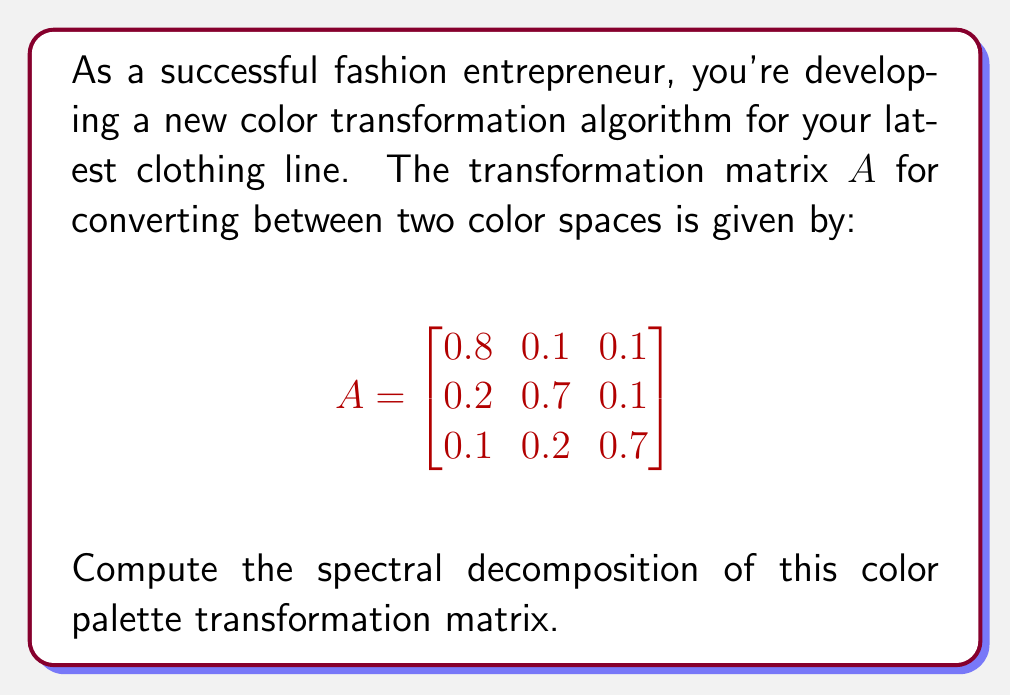Show me your answer to this math problem. To find the spectral decomposition of matrix $A$, we need to follow these steps:

1) Find the eigenvalues of $A$:
   Solve the characteristic equation $\det(A - \lambda I) = 0$
   
   $$\det\begin{pmatrix}
   0.8-\lambda & 0.1 & 0.1 \\
   0.2 & 0.7-\lambda & 0.1 \\
   0.1 & 0.2 & 0.7-\lambda
   \end{pmatrix} = 0$$
   
   Expanding this, we get:
   $-\lambda^3 + 2.2\lambda^2 - 1.51\lambda + 0.308 = 0$
   
   Solving this equation, we find the eigenvalues:
   $\lambda_1 = 1, \lambda_2 = 0.6, \lambda_3 = 0.6$

2) Find the eigenvectors for each eigenvalue:

   For $\lambda_1 = 1$:
   $(A - I)\vec{v_1} = 0$ gives $\vec{v_1} = (1, 1, 1)^T$

   For $\lambda_2 = \lambda_3 = 0.6$:
   $(A - 0.6I)\vec{v} = 0$ gives two linearly independent vectors:
   $\vec{v_2} = (-1, 0, 1)^T$ and $\vec{v_3} = (-1, 1, 0)^T$

3) Normalize the eigenvectors:
   $\vec{u_1} = \frac{1}{\sqrt{3}}(1, 1, 1)^T$
   $\vec{u_2} = \frac{1}{\sqrt{2}}(-1, 0, 1)^T$
   $\vec{u_3} = \frac{1}{\sqrt{2}}(-1, 1, 0)^T$

4) Form the matrix $P$ with these normalized eigenvectors as columns:
   $$P = \begin{bmatrix}
   \frac{1}{\sqrt{3}} & -\frac{1}{\sqrt{2}} & -\frac{1}{\sqrt{2}} \\
   \frac{1}{\sqrt{3}} & 0 & \frac{1}{\sqrt{2}} \\
   \frac{1}{\sqrt{3}} & \frac{1}{\sqrt{2}} & 0
   \end{bmatrix}$$

5) Form the diagonal matrix $D$ with eigenvalues:
   $$D = \begin{bmatrix}
   1 & 0 & 0 \\
   0 & 0.6 & 0 \\
   0 & 0 & 0.6
   \end{bmatrix}$$

The spectral decomposition is then $A = PDP^{-1}$.
Answer: $A = PDP^{-1}$, where $P = [\frac{1}{\sqrt{3}}(1,1,1)^T, \frac{1}{\sqrt{2}}(-1,0,1)^T, \frac{1}{\sqrt{2}}(-1,1,0)^T]$ and $D = \text{diag}(1, 0.6, 0.6)$ 